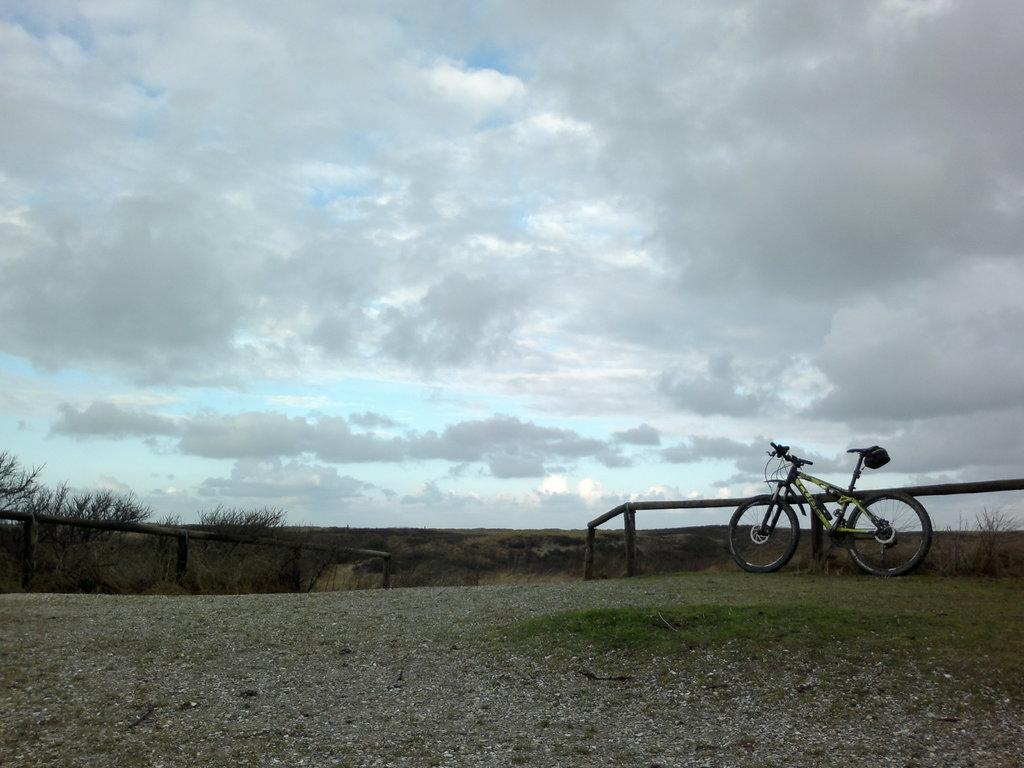What type of barrier is present on both sides of the image? There is a wooden fence on both the right and left sides of the image. What object can be seen on the right side of the image? There is a cycle on the right side of the image. What can be seen in the distance in the image? There are trees in the background of the image. What part of the natural environment is visible in the image? The sky is visible in the background of the image. How many chickens are sitting on the cycle in the image? There are no chickens present in the image, and the cycle is not being used as a perch for any animals. 